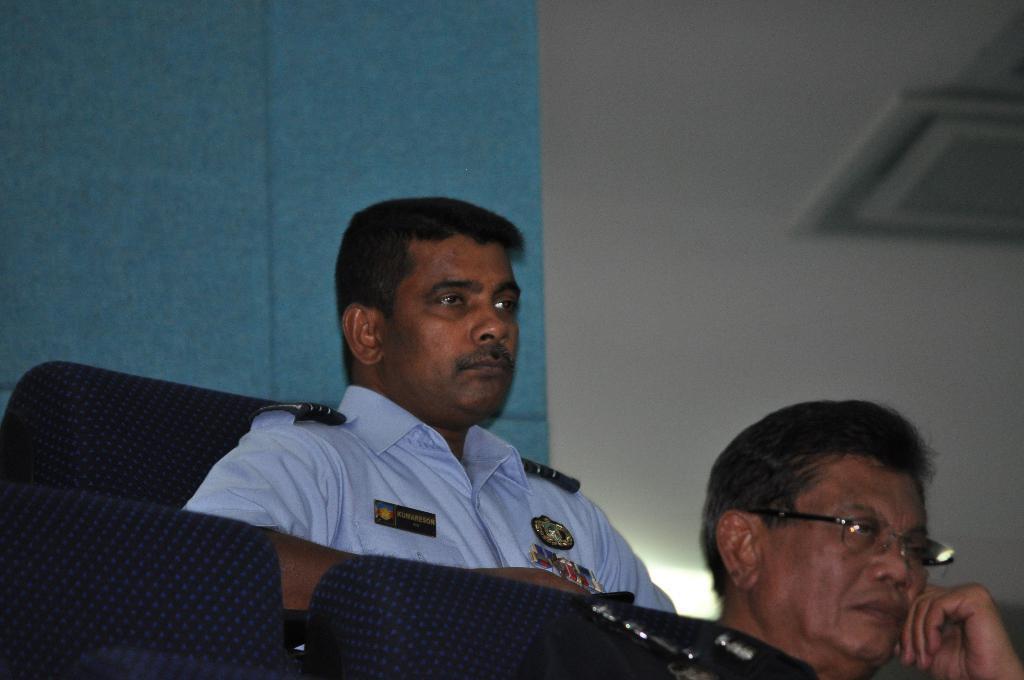Please provide a concise description of this image. At the bottom of the picture, we see two empty chairs and beside that, we see a man is sitting on the chair. Behind him, we see a man in the uniform is sitting on the chair. In the background, we see a wall in white and blue color. In the right top, we see an object in white color. 